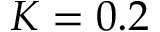Convert formula to latex. <formula><loc_0><loc_0><loc_500><loc_500>K = 0 . 2</formula> 